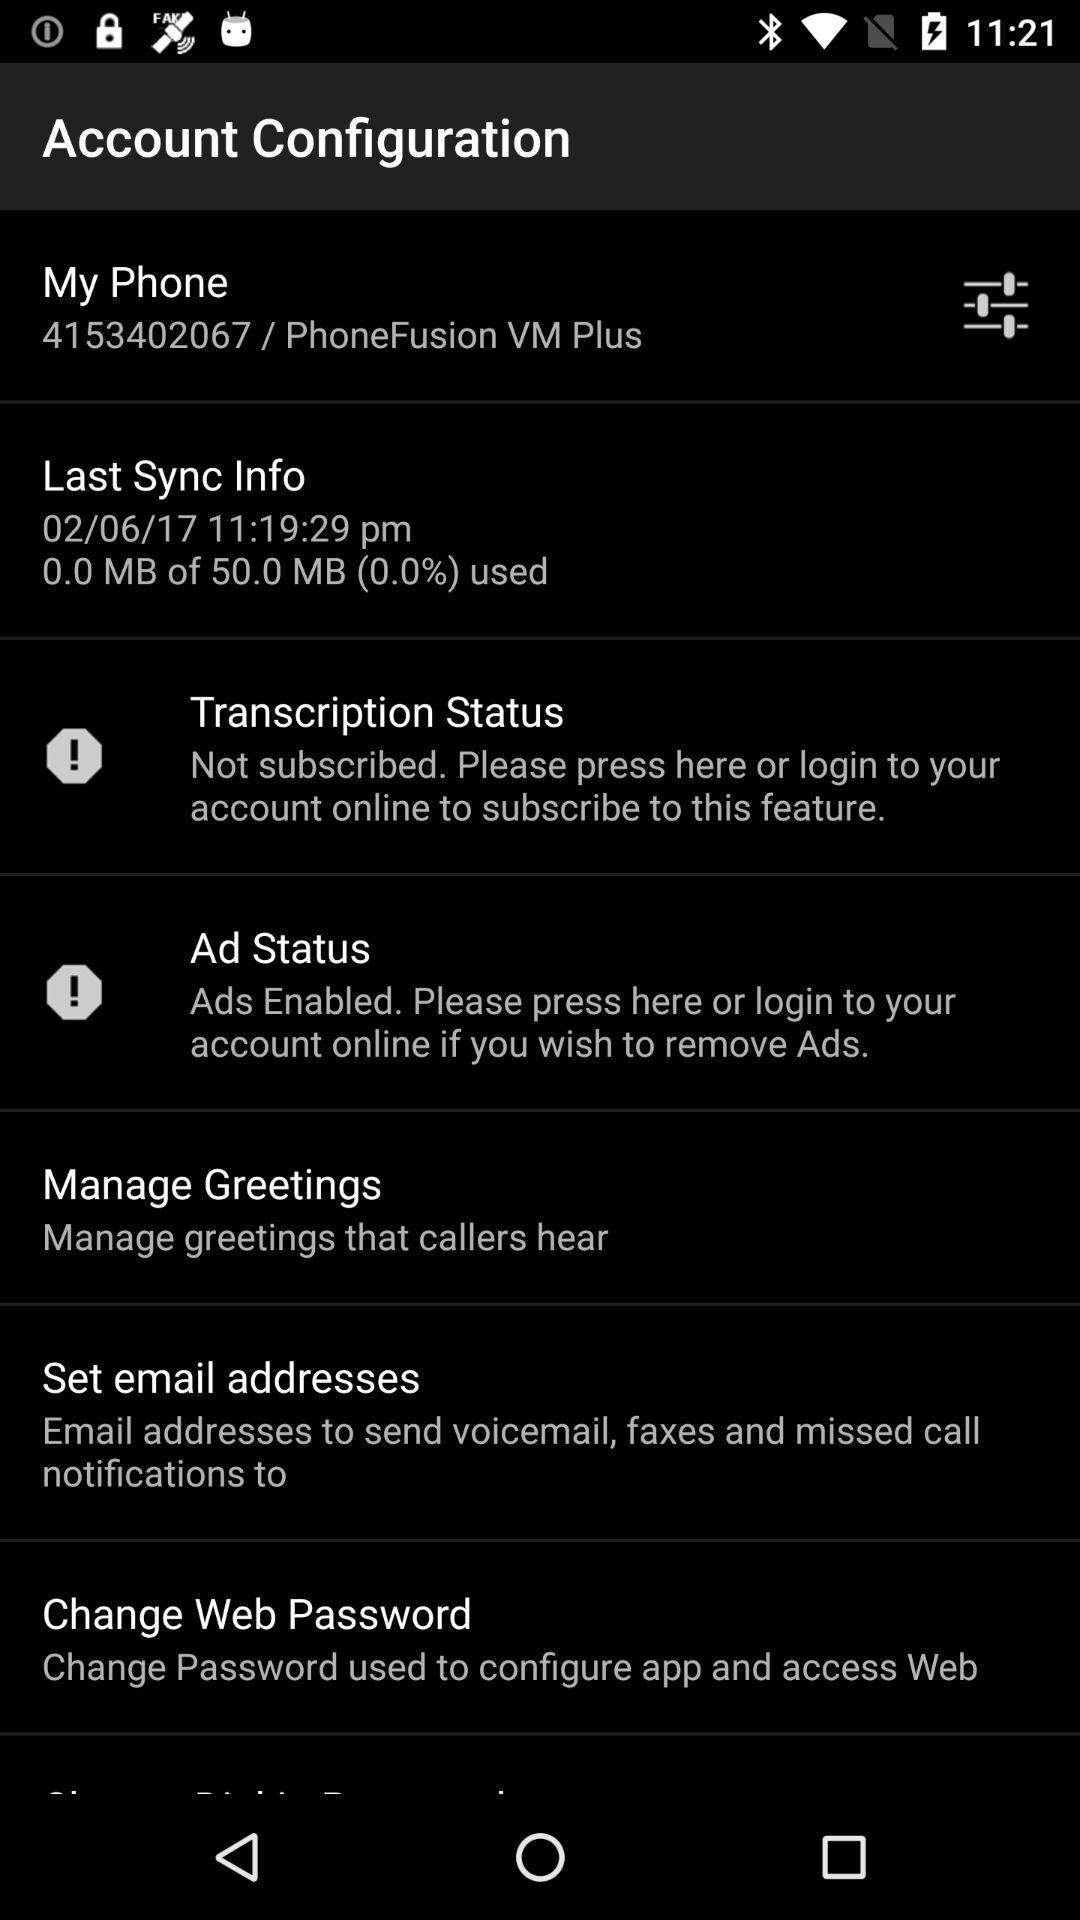What is the date of the last sync? The date of the last sync is June 2, 2017. 